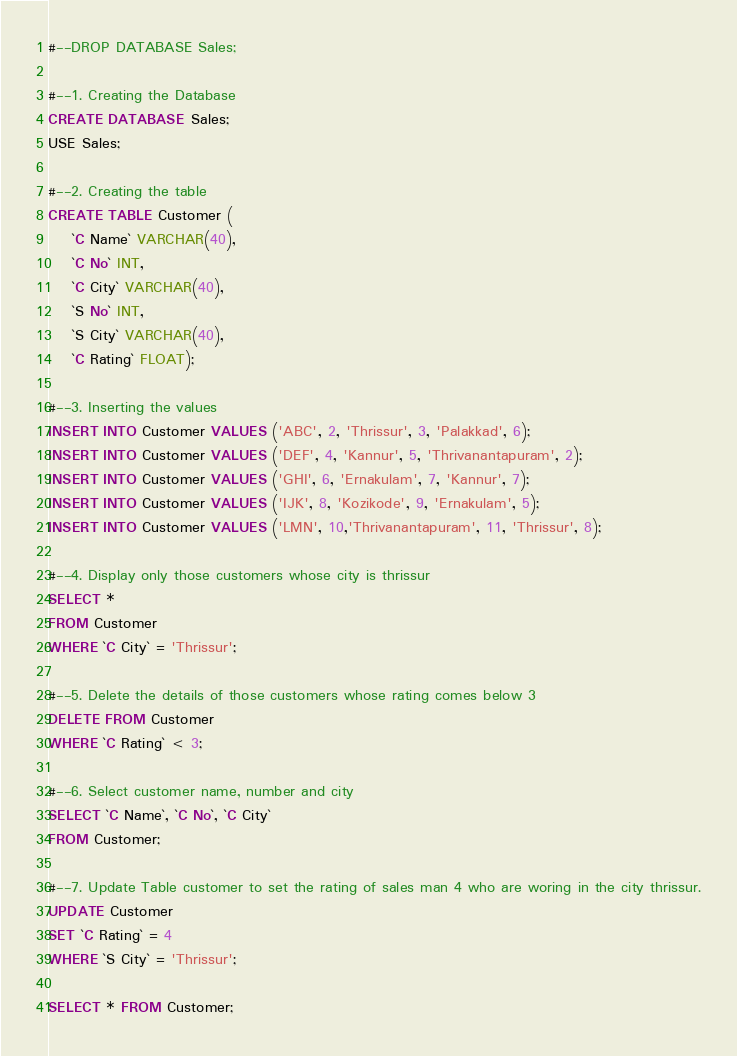Convert code to text. <code><loc_0><loc_0><loc_500><loc_500><_SQL_>#--DROP DATABASE Sales;

#--1. Creating the Database
CREATE DATABASE Sales;
USE Sales;

#--2. Creating the table
CREATE TABLE Customer (
	`C Name` VARCHAR(40),
	`C No` INT,
	`C City` VARCHAR(40),
	`S No` INT,
	`S City` VARCHAR(40),
	`C Rating` FLOAT);

#--3. Inserting the values
INSERT INTO Customer VALUES ('ABC', 2, 'Thrissur', 3, 'Palakkad', 6);
INSERT INTO Customer VALUES ('DEF', 4, 'Kannur', 5, 'Thrivanantapuram', 2);
INSERT INTO Customer VALUES ('GHI', 6, 'Ernakulam', 7, 'Kannur', 7);
INSERT INTO Customer VALUES ('IJK', 8, 'Kozikode', 9, 'Ernakulam', 5);
INSERT INTO Customer VALUES ('LMN', 10,'Thrivanantapuram', 11, 'Thrissur', 8);

#--4. Display only those customers whose city is thrissur
SELECT *
FROM Customer
WHERE `C City` = 'Thrissur';

#--5. Delete the details of those customers whose rating comes below 3
DELETE FROM Customer
WHERE `C Rating` < 3;

#--6. Select customer name, number and city
SELECT `C Name`, `C No`, `C City`
FROM Customer;

#--7. Update Table customer to set the rating of sales man 4 who are woring in the city thrissur.
UPDATE Customer
SET `C Rating` = 4
WHERE `S City` = 'Thrissur';

SELECT * FROM Customer;
</code> 